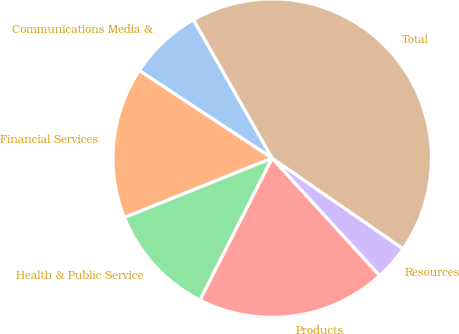Convert chart to OTSL. <chart><loc_0><loc_0><loc_500><loc_500><pie_chart><fcel>Communications Media &<fcel>Financial Services<fcel>Health & Public Service<fcel>Products<fcel>Resources<fcel>Total<nl><fcel>7.5%<fcel>15.36%<fcel>11.43%<fcel>19.29%<fcel>3.57%<fcel>42.87%<nl></chart> 